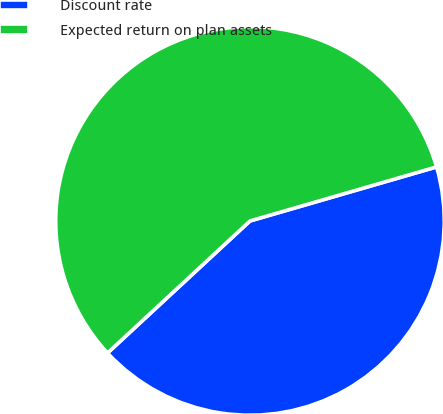Convert chart. <chart><loc_0><loc_0><loc_500><loc_500><pie_chart><fcel>Discount rate<fcel>Expected return on plan assets<nl><fcel>42.59%<fcel>57.41%<nl></chart> 